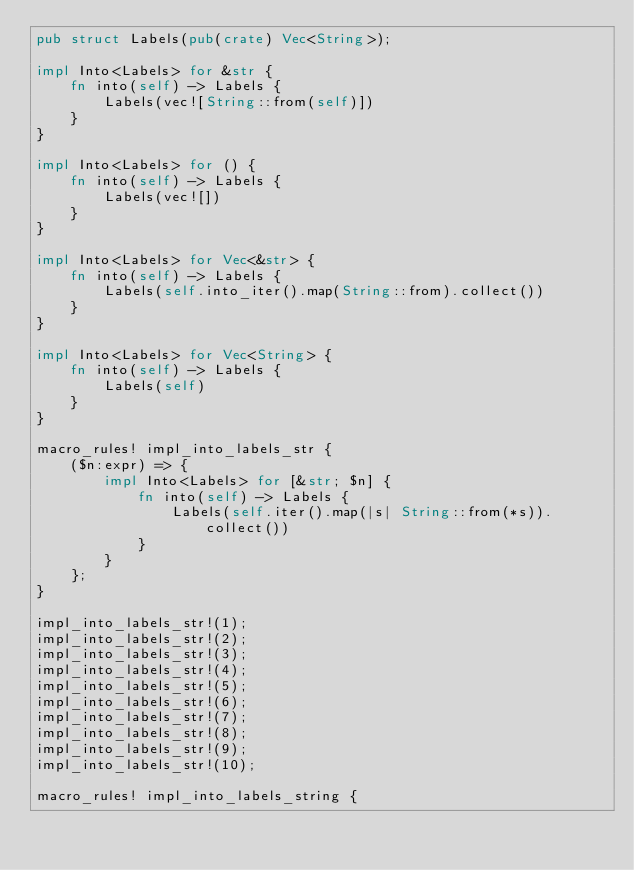<code> <loc_0><loc_0><loc_500><loc_500><_Rust_>pub struct Labels(pub(crate) Vec<String>);

impl Into<Labels> for &str {
    fn into(self) -> Labels {
        Labels(vec![String::from(self)])
    }
}

impl Into<Labels> for () {
    fn into(self) -> Labels {
        Labels(vec![])
    }
}

impl Into<Labels> for Vec<&str> {
    fn into(self) -> Labels {
        Labels(self.into_iter().map(String::from).collect())
    }
}

impl Into<Labels> for Vec<String> {
    fn into(self) -> Labels {
        Labels(self)
    }
}

macro_rules! impl_into_labels_str {
    ($n:expr) => {
        impl Into<Labels> for [&str; $n] {
            fn into(self) -> Labels {
                Labels(self.iter().map(|s| String::from(*s)).collect())
            }
        }
    };
}

impl_into_labels_str!(1);
impl_into_labels_str!(2);
impl_into_labels_str!(3);
impl_into_labels_str!(4);
impl_into_labels_str!(5);
impl_into_labels_str!(6);
impl_into_labels_str!(7);
impl_into_labels_str!(8);
impl_into_labels_str!(9);
impl_into_labels_str!(10);

macro_rules! impl_into_labels_string {</code> 